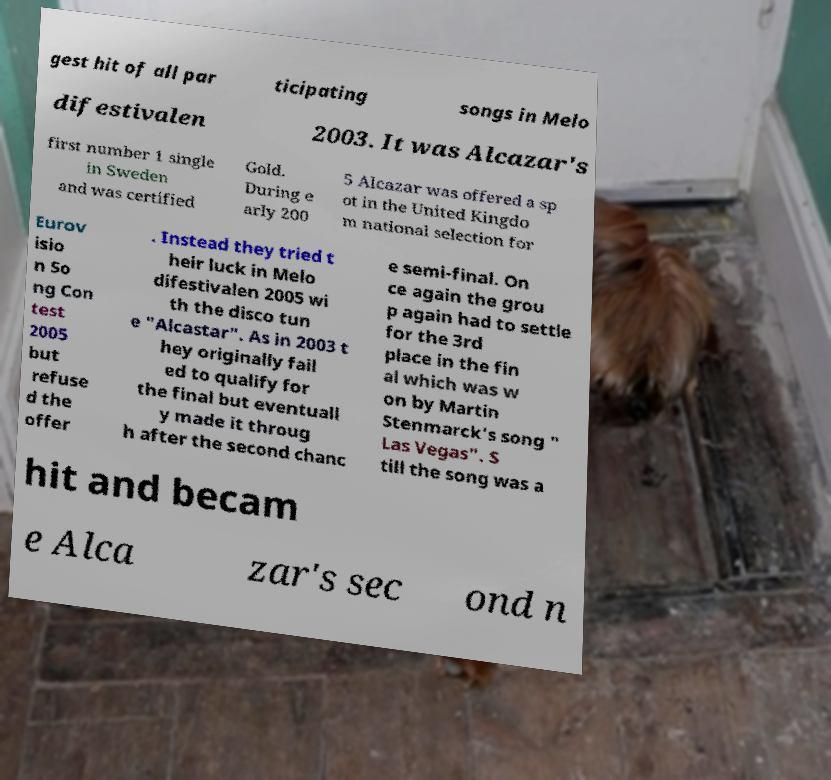Could you extract and type out the text from this image? gest hit of all par ticipating songs in Melo difestivalen 2003. It was Alcazar's first number 1 single in Sweden and was certified Gold. During e arly 200 5 Alcazar was offered a sp ot in the United Kingdo m national selection for Eurov isio n So ng Con test 2005 but refuse d the offer . Instead they tried t heir luck in Melo difestivalen 2005 wi th the disco tun e "Alcastar". As in 2003 t hey originally fail ed to qualify for the final but eventuall y made it throug h after the second chanc e semi-final. On ce again the grou p again had to settle for the 3rd place in the fin al which was w on by Martin Stenmarck's song " Las Vegas". S till the song was a hit and becam e Alca zar's sec ond n 